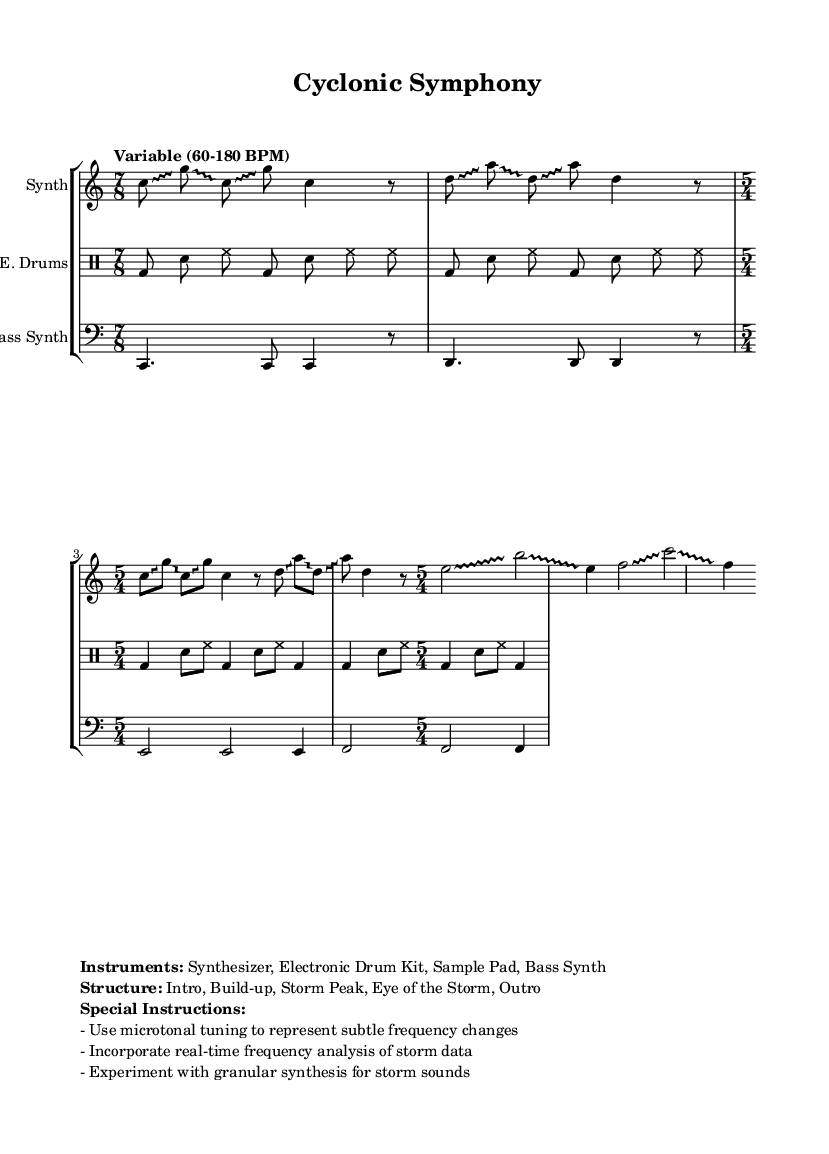What is the time signature of the first section? The time signature of the first section is 7/8, which is indicated at the beginning of that section.
Answer: 7/8 What is the tempo range indicated in the sheet music? The tempo range indicated is "Variable (60-180 BPM," suggesting that the tempo can change within this range.
Answer: Variable (60-180 BPM) Which instruments are used in this composition? The instruments listed in the markup section include Synthesizer, Electronic Drum Kit, Sample Pad, and Bass Synth.
Answer: Synthesizer, Electronic Drum Kit, Sample Pad, Bass Synth What are the sections of the composition? The sections specified are Intro, Build-up, Storm Peak, Eye of the Storm, and Outro, which outlines the overall structure of the piece.
Answer: Intro, Build-up, Storm Peak, Eye of the Storm, Outro Why is microtonal tuning specified in the instructions? Microtonal tuning is specified to represent subtle frequency changes that may occur during storm systems, enhancing the experimental nature of the music and its relationship to weather phenomena.
Answer: To represent subtle frequency changes What does "granular synthesis" refer to in this context? Granular synthesis in this context refers to a sound synthesis method that involves splitting sounds into small grains and manipulating them, which can create storm-like sounds to align with the theme.
Answer: A sound synthesis method for storm sounds How is the drum pattern structured in the second section? The drum pattern in the second section alternates between a bass drum (bd), snare (sn), and hi-hat (hh), changing to a 5/4 time signature, suggesting a changing rhythm that contributes to the 'stormy' feel.
Answer: Alternates with bass drum, snare, hi-hat in 5/4 